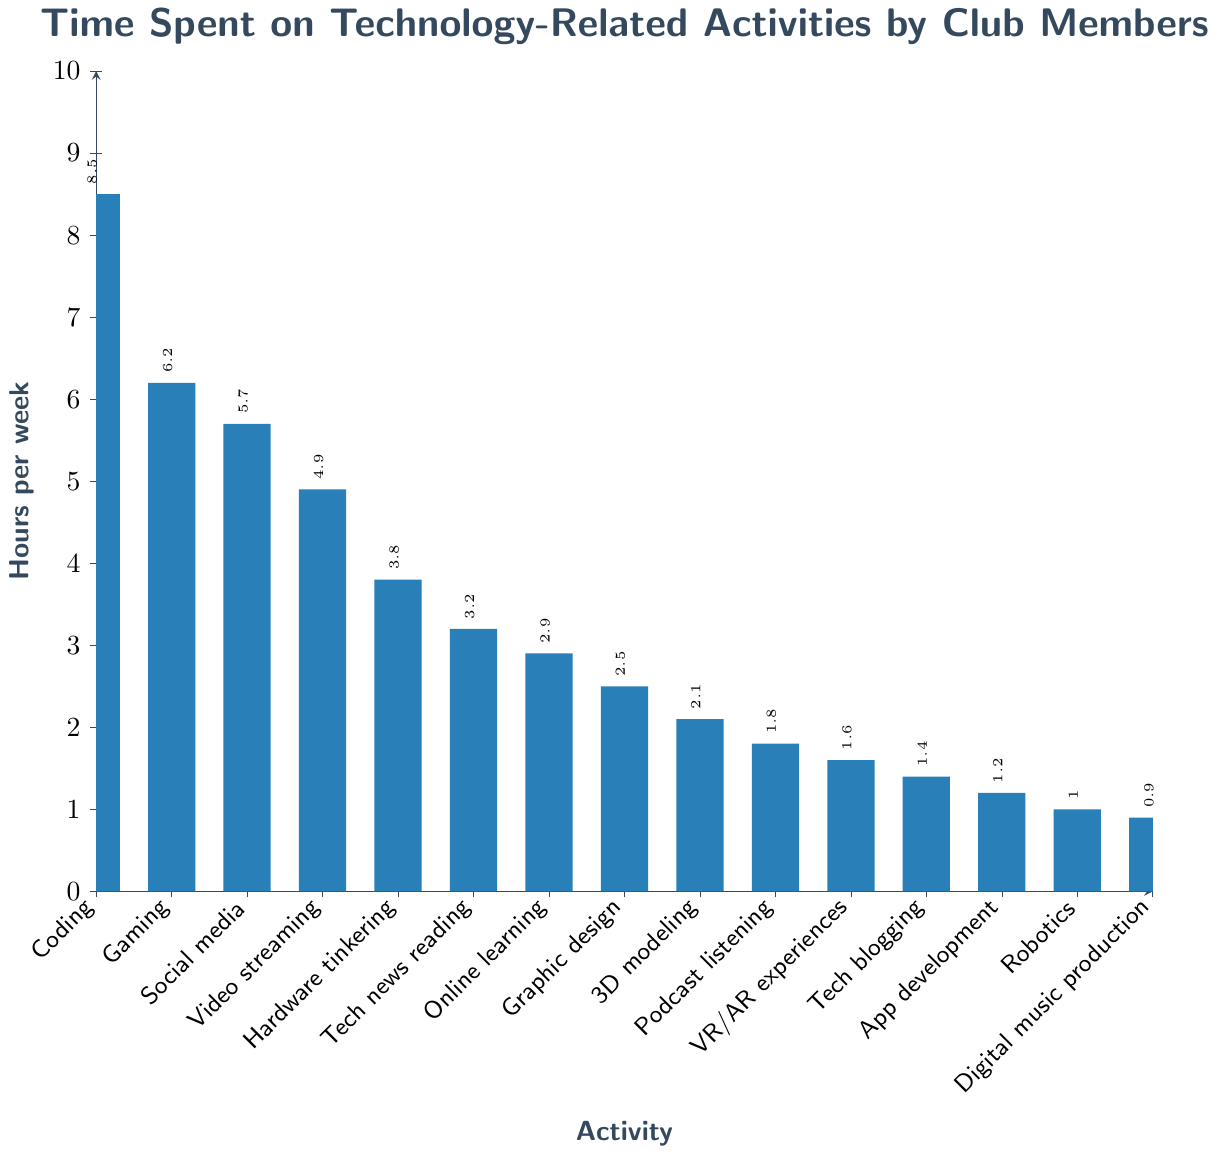What activity has the highest average weekly hours? The bar representing coding is the tallest, indicating the most hours spent per week.
Answer: Coding What is the total time spent on both Gaming and Social media per week? Add the time spent on Gaming and Social media: 6.2 + 5.7 = 11.9 hours per week.
Answer: 11.9 hours Which activities are performed for less than 2 hours per week? Identify the activities with bars shorter than the 2-hour line: Podcast listening, VR/AR experiences, Tech blogging, App development, Robotics, Digital music production.
Answer: Podcast listening, VR/AR experiences, Tech blogging, App development, Robotics, Digital music production How much more time is spent on Video streaming than Tech news reading? Subtract the hours for Tech news reading from Video streaming: 4.9 - 3.2 = 1.7 hours.
Answer: 1.7 hours What is the average time spent on Online learning, Graphic design, and Tech news reading? Add the hours for Online learning, Graphic design, and Tech news reading, then divide by the number of activities: (2.9 + 2.5 + 3.2) / 3 = 2.87 hours.
Answer: 2.87 hours Which activities have the same average weekly hours? Identify bars of equal height. There are no bars of equal height in this chart.
Answer: None What's the total time spent on all activities per week? Sum the weekly hours for all activities: 8.5 + 6.2 + 5.7 + 4.9 + 3.8 + 3.2 + 2.9 + 2.5 + 2.1 + 1.8 + 1.6 + 1.4 + 1.2 + 1.0 + 0.9 = 47.7 hours.
Answer: 47.7 hours Which two activities together amount to 10 hours per week? Look for two activities whose time sums to 10. Coding and Video streaming together total 8.5 + 1.5 = 10. However, no exact match is found.
Answer: No exact match 